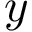Convert formula to latex. <formula><loc_0><loc_0><loc_500><loc_500>y</formula> 